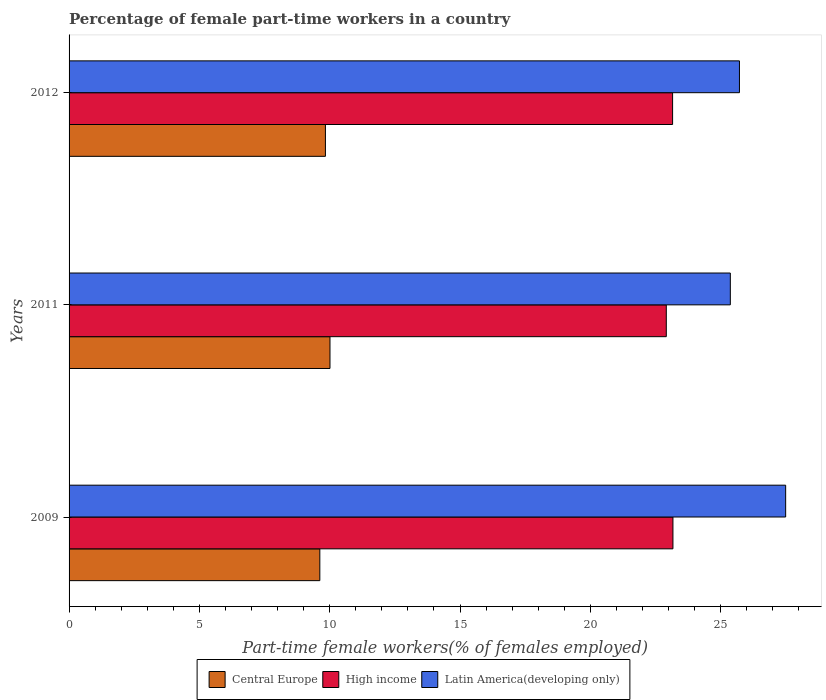How many different coloured bars are there?
Your response must be concise. 3. Are the number of bars per tick equal to the number of legend labels?
Offer a very short reply. Yes. What is the label of the 2nd group of bars from the top?
Your response must be concise. 2011. What is the percentage of female part-time workers in High income in 2012?
Offer a very short reply. 23.16. Across all years, what is the maximum percentage of female part-time workers in High income?
Make the answer very short. 23.17. Across all years, what is the minimum percentage of female part-time workers in High income?
Make the answer very short. 22.91. What is the total percentage of female part-time workers in Latin America(developing only) in the graph?
Your answer should be very brief. 78.59. What is the difference between the percentage of female part-time workers in High income in 2011 and that in 2012?
Your response must be concise. -0.24. What is the difference between the percentage of female part-time workers in Latin America(developing only) in 2009 and the percentage of female part-time workers in Central Europe in 2011?
Provide a short and direct response. 17.48. What is the average percentage of female part-time workers in Central Europe per year?
Your answer should be very brief. 9.82. In the year 2009, what is the difference between the percentage of female part-time workers in Central Europe and percentage of female part-time workers in High income?
Your answer should be compact. -13.55. In how many years, is the percentage of female part-time workers in Latin America(developing only) greater than 3 %?
Ensure brevity in your answer.  3. What is the ratio of the percentage of female part-time workers in Latin America(developing only) in 2009 to that in 2011?
Give a very brief answer. 1.08. What is the difference between the highest and the second highest percentage of female part-time workers in Latin America(developing only)?
Ensure brevity in your answer.  1.77. What is the difference between the highest and the lowest percentage of female part-time workers in High income?
Provide a short and direct response. 0.25. What does the 3rd bar from the top in 2012 represents?
Offer a terse response. Central Europe. What does the 3rd bar from the bottom in 2012 represents?
Make the answer very short. Latin America(developing only). Is it the case that in every year, the sum of the percentage of female part-time workers in Central Europe and percentage of female part-time workers in Latin America(developing only) is greater than the percentage of female part-time workers in High income?
Offer a terse response. Yes. How are the legend labels stacked?
Keep it short and to the point. Horizontal. What is the title of the graph?
Offer a terse response. Percentage of female part-time workers in a country. What is the label or title of the X-axis?
Offer a terse response. Part-time female workers(% of females employed). What is the Part-time female workers(% of females employed) of Central Europe in 2009?
Provide a short and direct response. 9.62. What is the Part-time female workers(% of females employed) in High income in 2009?
Ensure brevity in your answer.  23.17. What is the Part-time female workers(% of females employed) in Latin America(developing only) in 2009?
Keep it short and to the point. 27.49. What is the Part-time female workers(% of females employed) in Central Europe in 2011?
Keep it short and to the point. 10.01. What is the Part-time female workers(% of females employed) of High income in 2011?
Provide a short and direct response. 22.91. What is the Part-time female workers(% of females employed) in Latin America(developing only) in 2011?
Offer a very short reply. 25.37. What is the Part-time female workers(% of females employed) of Central Europe in 2012?
Keep it short and to the point. 9.84. What is the Part-time female workers(% of females employed) in High income in 2012?
Ensure brevity in your answer.  23.16. What is the Part-time female workers(% of females employed) in Latin America(developing only) in 2012?
Offer a terse response. 25.72. Across all years, what is the maximum Part-time female workers(% of females employed) in Central Europe?
Provide a short and direct response. 10.01. Across all years, what is the maximum Part-time female workers(% of females employed) in High income?
Provide a succinct answer. 23.17. Across all years, what is the maximum Part-time female workers(% of females employed) of Latin America(developing only)?
Your answer should be very brief. 27.49. Across all years, what is the minimum Part-time female workers(% of females employed) in Central Europe?
Offer a terse response. 9.62. Across all years, what is the minimum Part-time female workers(% of females employed) of High income?
Keep it short and to the point. 22.91. Across all years, what is the minimum Part-time female workers(% of females employed) in Latin America(developing only)?
Provide a short and direct response. 25.37. What is the total Part-time female workers(% of females employed) in Central Europe in the graph?
Your answer should be very brief. 29.47. What is the total Part-time female workers(% of females employed) of High income in the graph?
Your answer should be very brief. 69.24. What is the total Part-time female workers(% of females employed) in Latin America(developing only) in the graph?
Give a very brief answer. 78.59. What is the difference between the Part-time female workers(% of females employed) of Central Europe in 2009 and that in 2011?
Offer a terse response. -0.39. What is the difference between the Part-time female workers(% of females employed) of High income in 2009 and that in 2011?
Keep it short and to the point. 0.25. What is the difference between the Part-time female workers(% of females employed) in Latin America(developing only) in 2009 and that in 2011?
Offer a terse response. 2.12. What is the difference between the Part-time female workers(% of females employed) of Central Europe in 2009 and that in 2012?
Offer a very short reply. -0.21. What is the difference between the Part-time female workers(% of females employed) of High income in 2009 and that in 2012?
Ensure brevity in your answer.  0.01. What is the difference between the Part-time female workers(% of females employed) in Latin America(developing only) in 2009 and that in 2012?
Your answer should be very brief. 1.77. What is the difference between the Part-time female workers(% of females employed) in Central Europe in 2011 and that in 2012?
Your answer should be very brief. 0.17. What is the difference between the Part-time female workers(% of females employed) in High income in 2011 and that in 2012?
Ensure brevity in your answer.  -0.24. What is the difference between the Part-time female workers(% of females employed) in Latin America(developing only) in 2011 and that in 2012?
Ensure brevity in your answer.  -0.35. What is the difference between the Part-time female workers(% of females employed) in Central Europe in 2009 and the Part-time female workers(% of females employed) in High income in 2011?
Your response must be concise. -13.29. What is the difference between the Part-time female workers(% of females employed) of Central Europe in 2009 and the Part-time female workers(% of females employed) of Latin America(developing only) in 2011?
Offer a very short reply. -15.75. What is the difference between the Part-time female workers(% of females employed) of High income in 2009 and the Part-time female workers(% of females employed) of Latin America(developing only) in 2011?
Give a very brief answer. -2.2. What is the difference between the Part-time female workers(% of females employed) in Central Europe in 2009 and the Part-time female workers(% of females employed) in High income in 2012?
Offer a very short reply. -13.54. What is the difference between the Part-time female workers(% of females employed) of Central Europe in 2009 and the Part-time female workers(% of females employed) of Latin America(developing only) in 2012?
Provide a short and direct response. -16.1. What is the difference between the Part-time female workers(% of females employed) of High income in 2009 and the Part-time female workers(% of females employed) of Latin America(developing only) in 2012?
Offer a very short reply. -2.55. What is the difference between the Part-time female workers(% of females employed) in Central Europe in 2011 and the Part-time female workers(% of females employed) in High income in 2012?
Offer a terse response. -13.15. What is the difference between the Part-time female workers(% of females employed) of Central Europe in 2011 and the Part-time female workers(% of females employed) of Latin America(developing only) in 2012?
Make the answer very short. -15.71. What is the difference between the Part-time female workers(% of females employed) in High income in 2011 and the Part-time female workers(% of females employed) in Latin America(developing only) in 2012?
Ensure brevity in your answer.  -2.81. What is the average Part-time female workers(% of females employed) of Central Europe per year?
Your answer should be very brief. 9.82. What is the average Part-time female workers(% of females employed) of High income per year?
Keep it short and to the point. 23.08. What is the average Part-time female workers(% of females employed) in Latin America(developing only) per year?
Make the answer very short. 26.2. In the year 2009, what is the difference between the Part-time female workers(% of females employed) in Central Europe and Part-time female workers(% of females employed) in High income?
Offer a very short reply. -13.55. In the year 2009, what is the difference between the Part-time female workers(% of females employed) in Central Europe and Part-time female workers(% of females employed) in Latin America(developing only)?
Offer a terse response. -17.87. In the year 2009, what is the difference between the Part-time female workers(% of females employed) in High income and Part-time female workers(% of females employed) in Latin America(developing only)?
Offer a terse response. -4.33. In the year 2011, what is the difference between the Part-time female workers(% of females employed) of Central Europe and Part-time female workers(% of females employed) of High income?
Offer a terse response. -12.9. In the year 2011, what is the difference between the Part-time female workers(% of females employed) in Central Europe and Part-time female workers(% of females employed) in Latin America(developing only)?
Ensure brevity in your answer.  -15.36. In the year 2011, what is the difference between the Part-time female workers(% of females employed) of High income and Part-time female workers(% of females employed) of Latin America(developing only)?
Offer a very short reply. -2.46. In the year 2012, what is the difference between the Part-time female workers(% of females employed) of Central Europe and Part-time female workers(% of females employed) of High income?
Make the answer very short. -13.32. In the year 2012, what is the difference between the Part-time female workers(% of females employed) of Central Europe and Part-time female workers(% of females employed) of Latin America(developing only)?
Provide a succinct answer. -15.89. In the year 2012, what is the difference between the Part-time female workers(% of females employed) of High income and Part-time female workers(% of females employed) of Latin America(developing only)?
Make the answer very short. -2.56. What is the ratio of the Part-time female workers(% of females employed) of Central Europe in 2009 to that in 2011?
Your answer should be very brief. 0.96. What is the ratio of the Part-time female workers(% of females employed) of High income in 2009 to that in 2011?
Make the answer very short. 1.01. What is the ratio of the Part-time female workers(% of females employed) in Latin America(developing only) in 2009 to that in 2011?
Provide a succinct answer. 1.08. What is the ratio of the Part-time female workers(% of females employed) in Central Europe in 2009 to that in 2012?
Give a very brief answer. 0.98. What is the ratio of the Part-time female workers(% of females employed) in Latin America(developing only) in 2009 to that in 2012?
Provide a succinct answer. 1.07. What is the ratio of the Part-time female workers(% of females employed) in Central Europe in 2011 to that in 2012?
Provide a short and direct response. 1.02. What is the ratio of the Part-time female workers(% of females employed) of Latin America(developing only) in 2011 to that in 2012?
Your answer should be compact. 0.99. What is the difference between the highest and the second highest Part-time female workers(% of females employed) in Central Europe?
Ensure brevity in your answer.  0.17. What is the difference between the highest and the second highest Part-time female workers(% of females employed) of High income?
Keep it short and to the point. 0.01. What is the difference between the highest and the second highest Part-time female workers(% of females employed) in Latin America(developing only)?
Provide a succinct answer. 1.77. What is the difference between the highest and the lowest Part-time female workers(% of females employed) in Central Europe?
Make the answer very short. 0.39. What is the difference between the highest and the lowest Part-time female workers(% of females employed) of High income?
Give a very brief answer. 0.25. What is the difference between the highest and the lowest Part-time female workers(% of females employed) of Latin America(developing only)?
Your answer should be very brief. 2.12. 